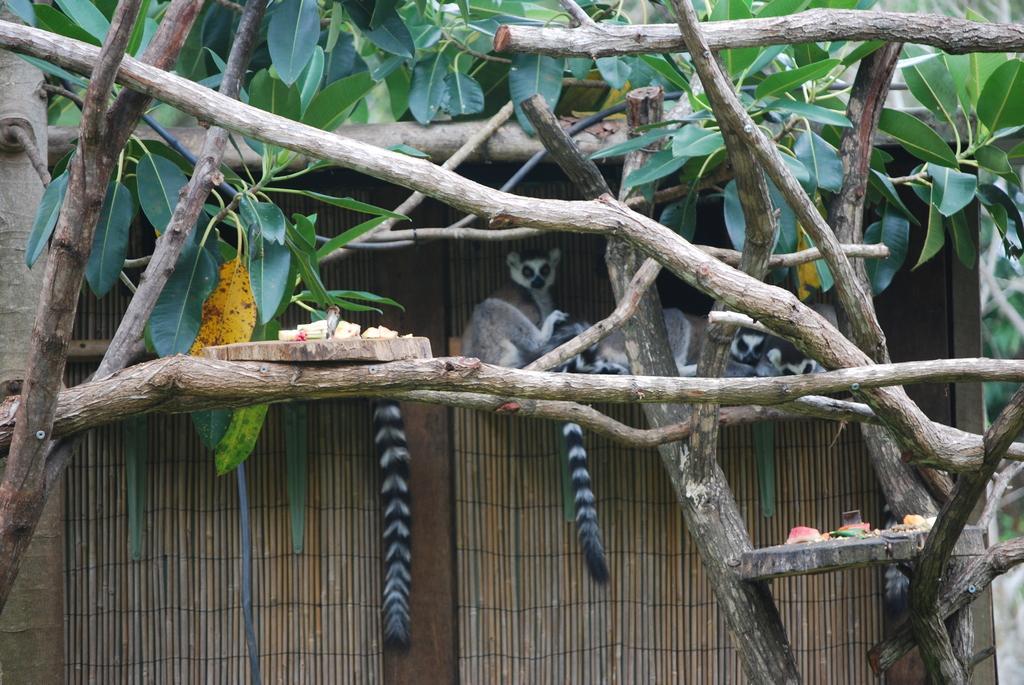Can you describe this image briefly? On the left side, there are food items arranged on a wooden plate, which is placed on a branch of a tree. On the right side, there are food items arranged on a wooden plate, which is placed on the branches of a tree. In the background, there are animals, a wall and trees. 